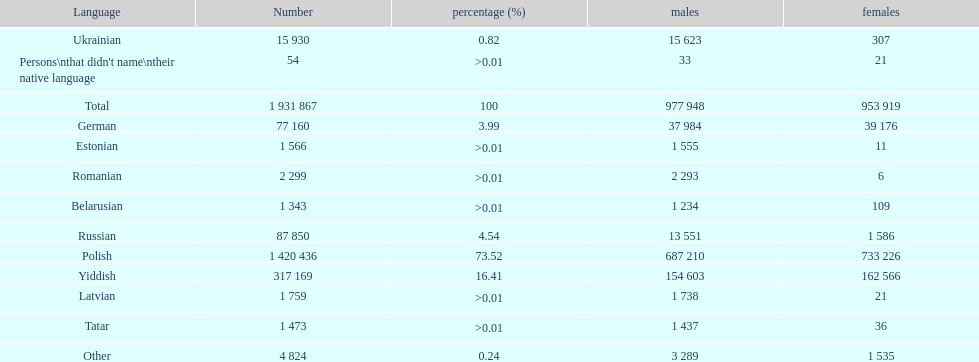What was the next most commonly spoken language in poland after russian? German. 